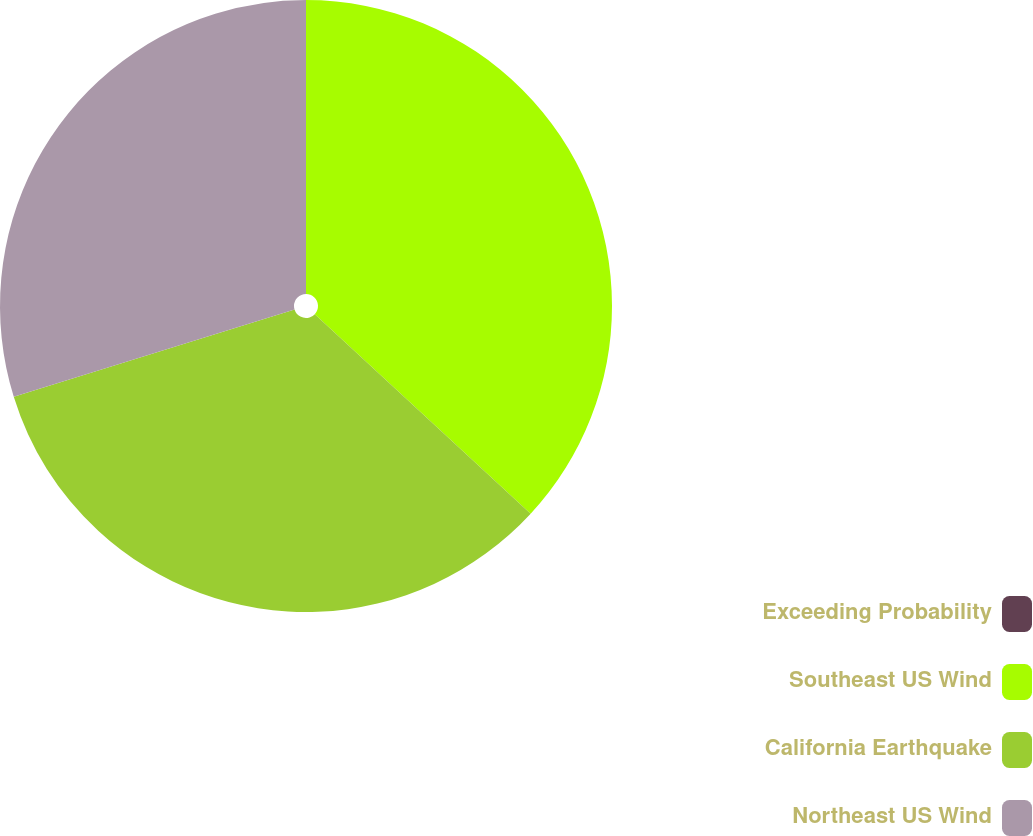<chart> <loc_0><loc_0><loc_500><loc_500><pie_chart><fcel>Exceeding Probability<fcel>Southeast US Wind<fcel>California Earthquake<fcel>Northeast US Wind<nl><fcel>0.0%<fcel>36.88%<fcel>33.33%<fcel>29.79%<nl></chart> 